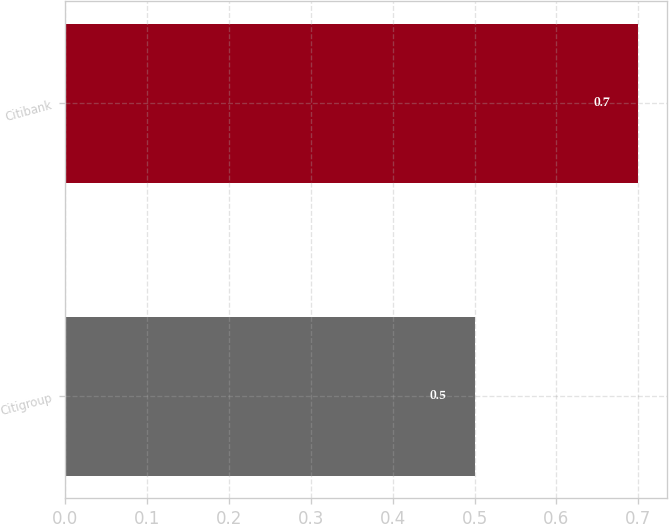<chart> <loc_0><loc_0><loc_500><loc_500><bar_chart><fcel>Citigroup<fcel>Citibank<nl><fcel>0.5<fcel>0.7<nl></chart> 